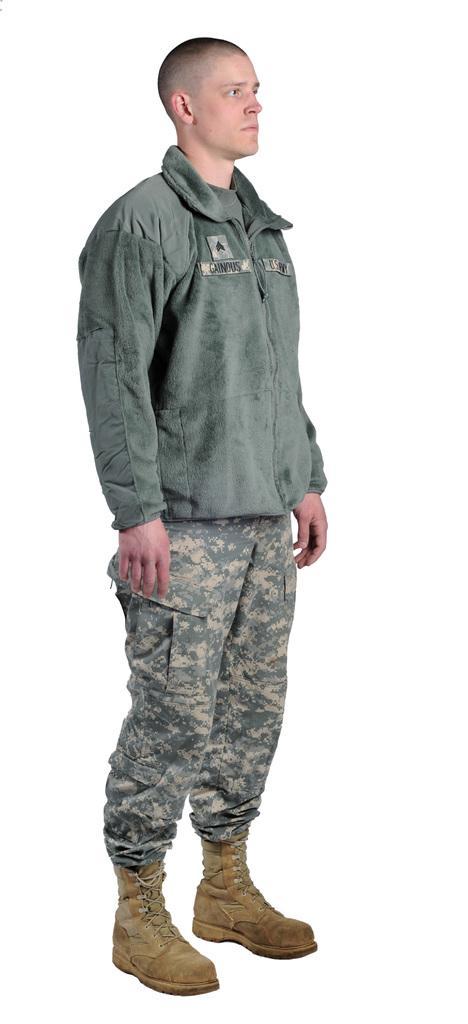Can you describe this image briefly? In this image I can see a man is standing. I can see he is wearing a jacket, camouflage pant and brown shoes. I can also see white colour in the background. 